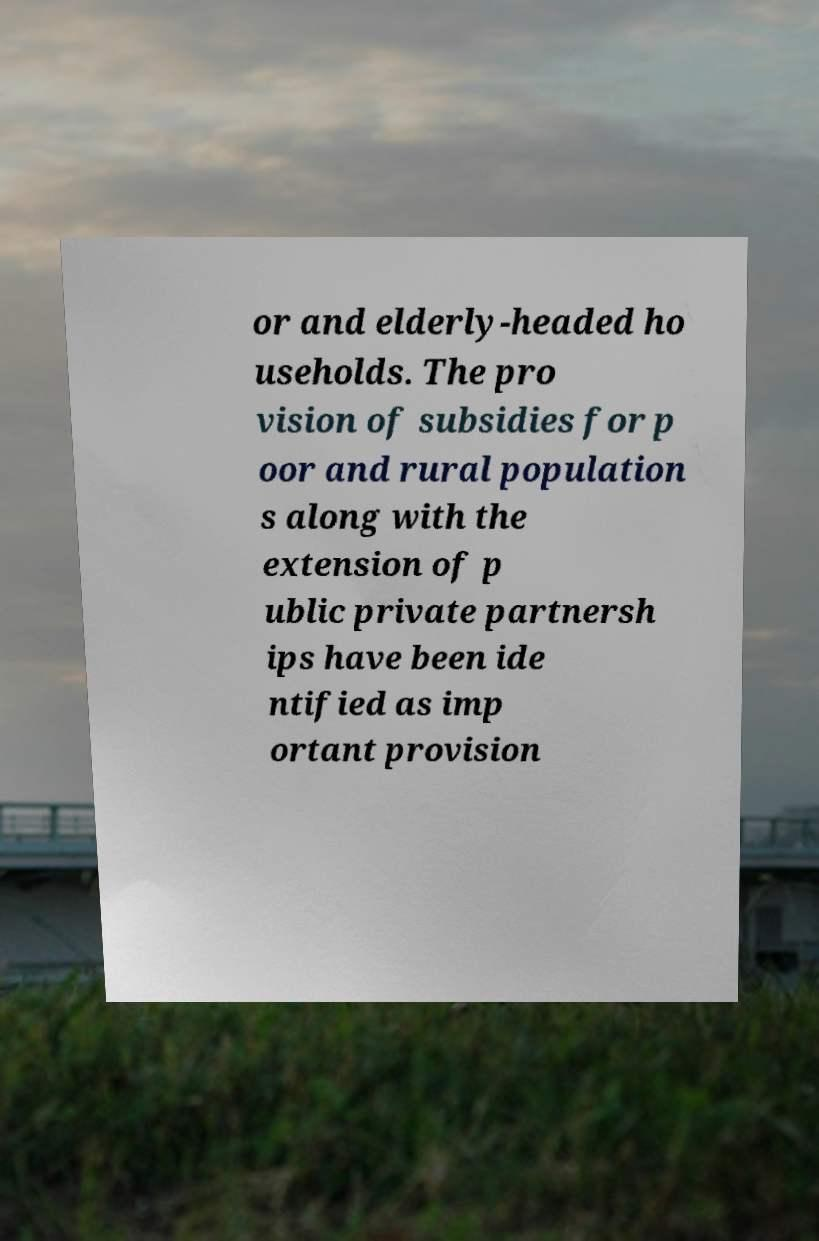Please identify and transcribe the text found in this image. or and elderly-headed ho useholds. The pro vision of subsidies for p oor and rural population s along with the extension of p ublic private partnersh ips have been ide ntified as imp ortant provision 